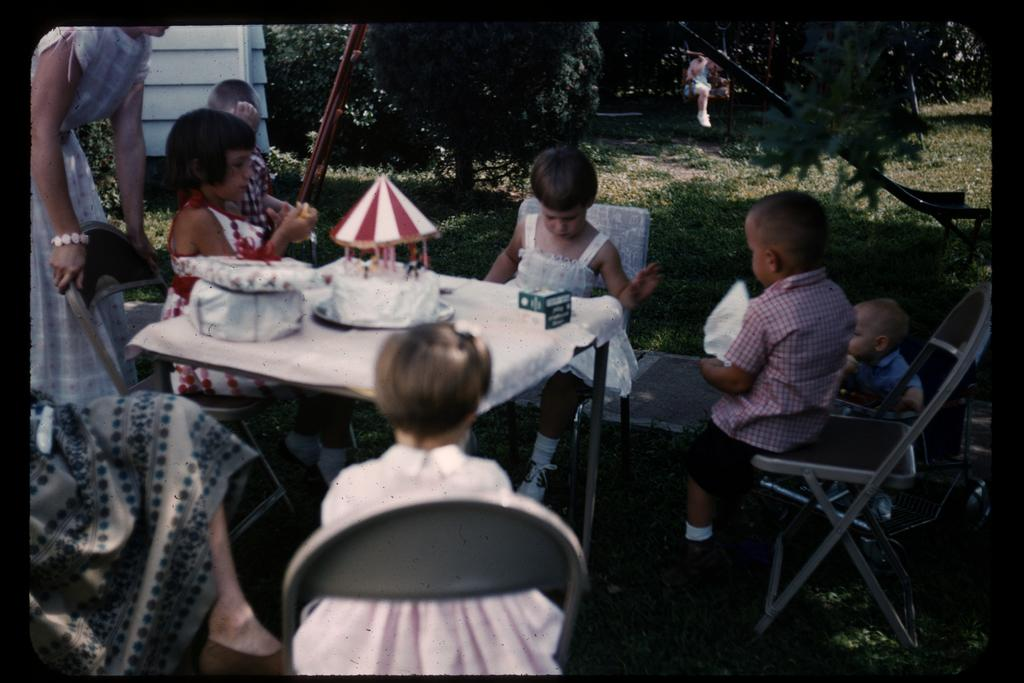What are the children doing in the image? The children are sitting on a chair at the table. What is on the table with the children? There is a cake and gifts on the table. What is the woman on the left side of the image doing? The woman is standing on the left side of the image. What can be seen in the background of the image? There are trees visible in the background of the image. How loud is the seashore in the image? There is no seashore present in the image; it features a table with children, a cake, and gifts, along with a woman and trees in the background. 